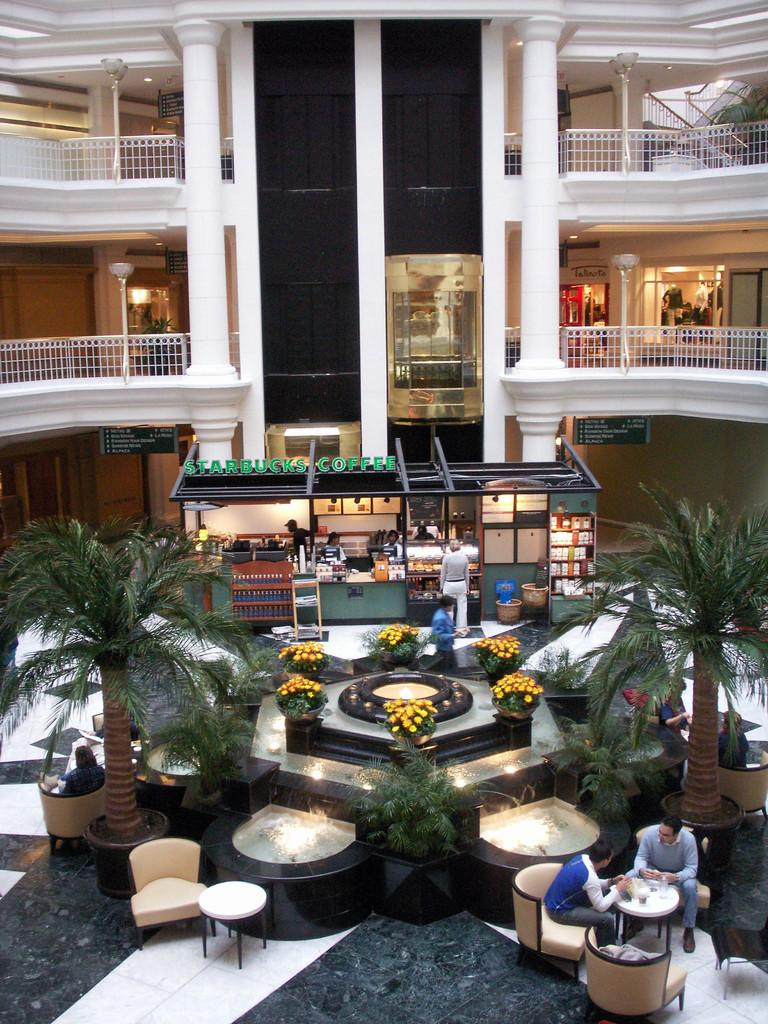<image>
Summarize the visual content of the image. The small store selling coffee in the building is Starbucks Coffee. 